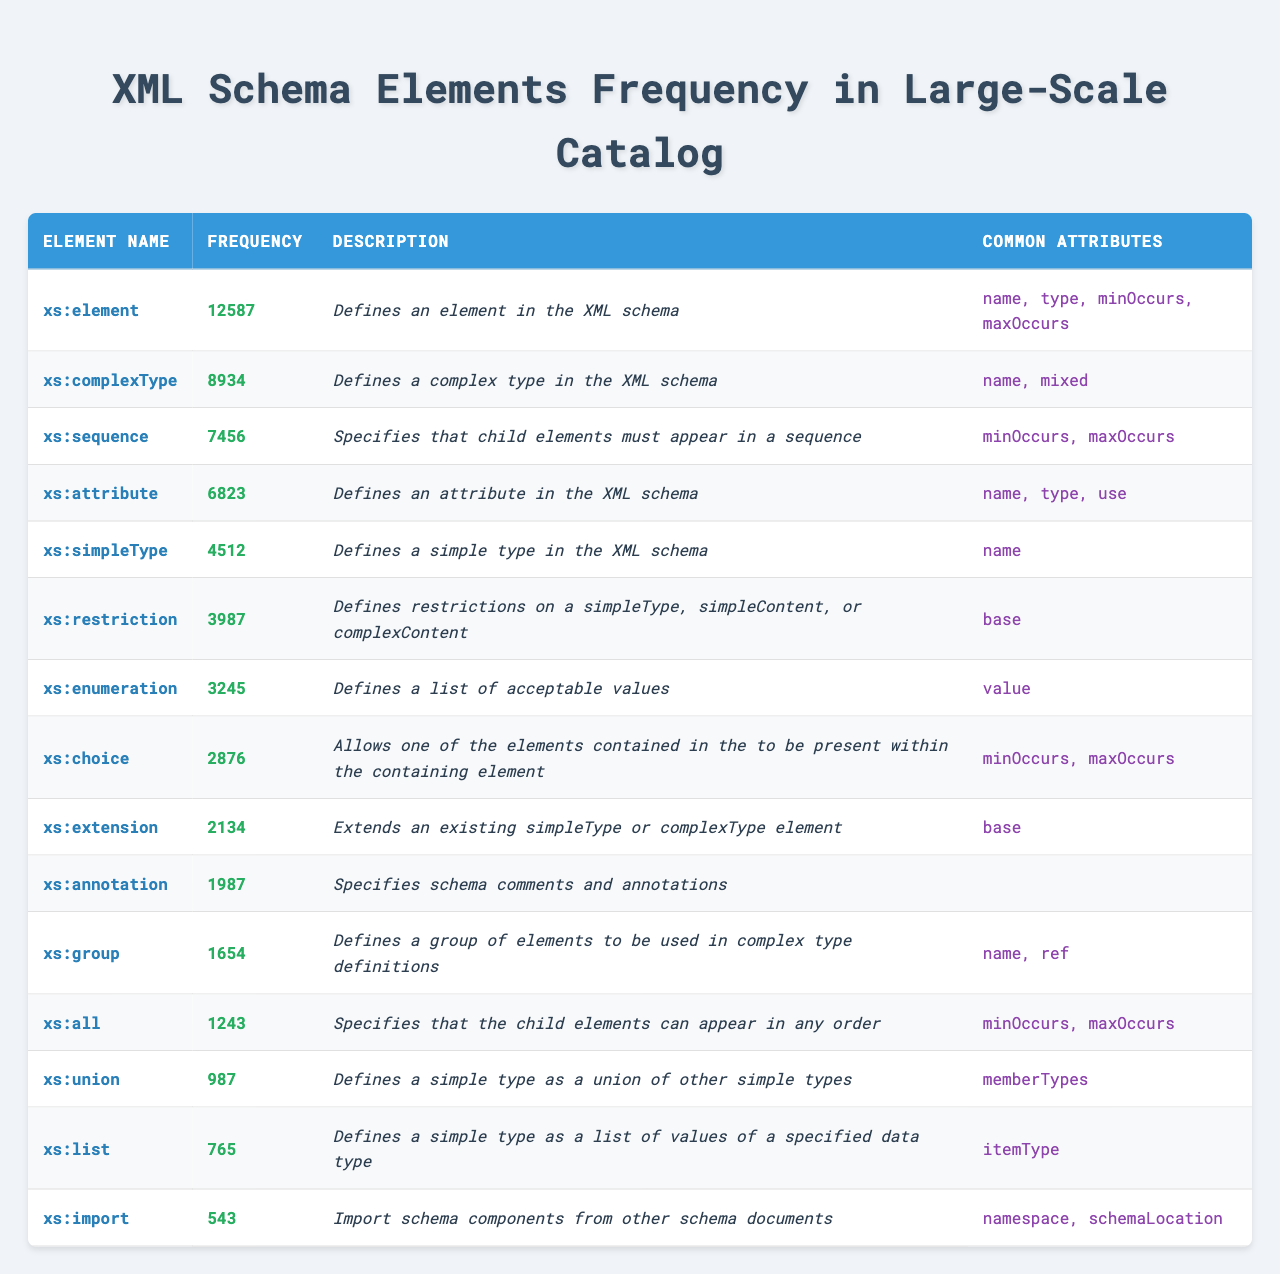What is the most frequently used XML Schema element? The table lists the frequencies of each element, and the highest frequency is 12587 for "xs:element."
Answer: xs:element How many times is "xs:simpleType" used in the catalog? According to the table, "xs:simpleType" has a frequency of 4512.
Answer: 4512 Which XML Schema element has the lowest frequency? By checking the frequencies, "xs:import" has the lowest count of 543.
Answer: xs:import What is the frequency difference between "xs:element" and "xs:attribute"? "xs:element" has a frequency of 12587, while "xs:attribute" has a frequency of 6823. The difference is 12587 - 6823 = 5764.
Answer: 5764 What percentage of the total frequencies does "xs:complexType" represent? The total frequency is obtained by summing all frequencies (12587 + 8934 + 7456 + 6823 + 4512 + 3987 + 3245 + 2876 + 2134 + 1987 + 1654 + 1243 + 987 + 765 + 543 = 38525). "xs:complexType" has a frequency of 8934, so the percentage is (8934 / 38525) * 100 = 23.2%.
Answer: 23.2% Is "xs:choice" used more than "xs:extension"? "xs:choice" has a frequency of 2876, while "xs:extension" has a frequency of 2134. Since 2876 is greater than 2134, the statement is true.
Answer: Yes Which element has the same common attribute as "xs:sequence"? "xs:sequence" has common attributes "minOccurs" and "maxOccurs." Checking the other elements, both "xs:choice" and "xs:all" also share these common attributes.
Answer: xs:choice and xs:all How many elements have a frequency greater than 3000? By examining the table, the elements with frequencies greater than 3000 are: "xs:element," "xs:complexType," "xs:attribute," "xs:restriction," "xs:enumeration," and "xs:choice." Counting these gives a total of 6 elements.
Answer: 6 What is the average frequency of the XML Schema elements listed? The sum of frequencies is 38525 and there are 15 elements. Therefore, the average frequency is 38525 / 15 = 2568.33, rounded to 2568.
Answer: 2568 Does "xs:annotation" define any common attributes? The description for "xs:annotation" mentions that it does not define any common attributes (it states an empty string). Hence, the answer is no.
Answer: No Which element can extend existing types and how frequently is it used? The element "xs:extension" is used to extend existing types and has a frequency of 2134.
Answer: xs:extension, 2134 